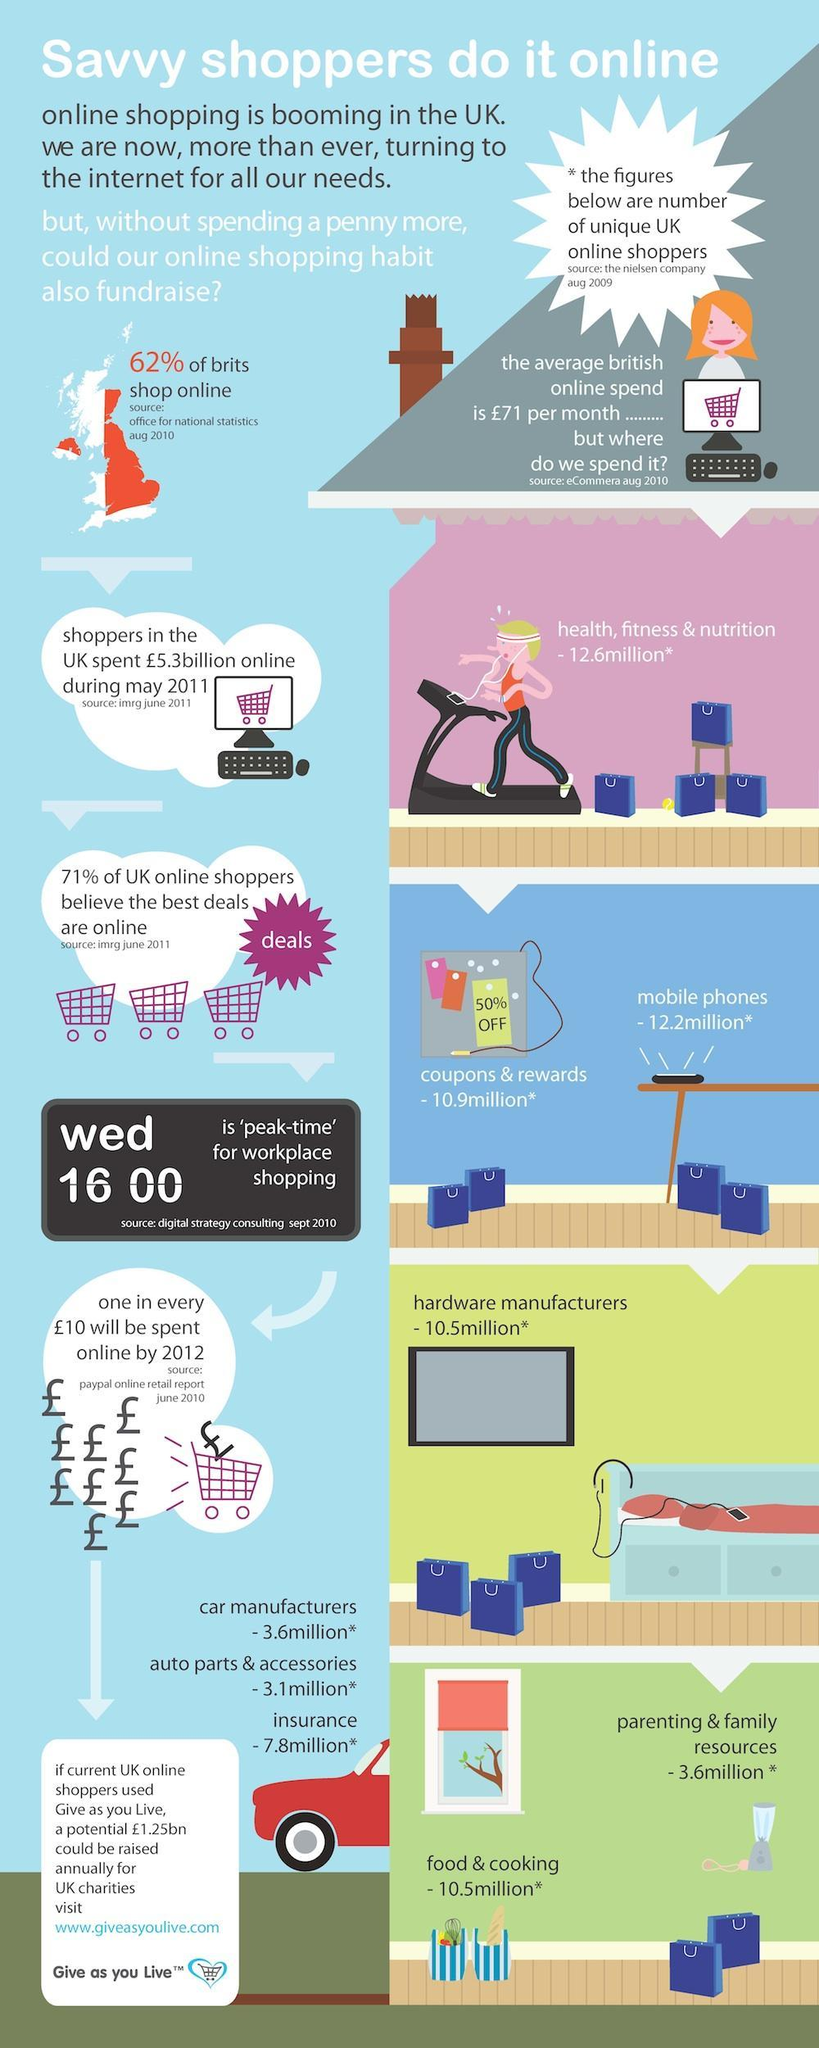What % of money spent will be spent online by 2012
Answer the question with a short phrase. 10 Which week day and time of the week is the peak time for workplace shopping wed, 1600 What has been the total spend in million on parenting and family resources and food & cooking 14.1 what has been the value of insurance 7.8million* what is the colour of the shopping trolley, violet or white violet what is the spend on health, fitness & nutrition 12.6million* what is the spend on mobile phones 12.2million* 